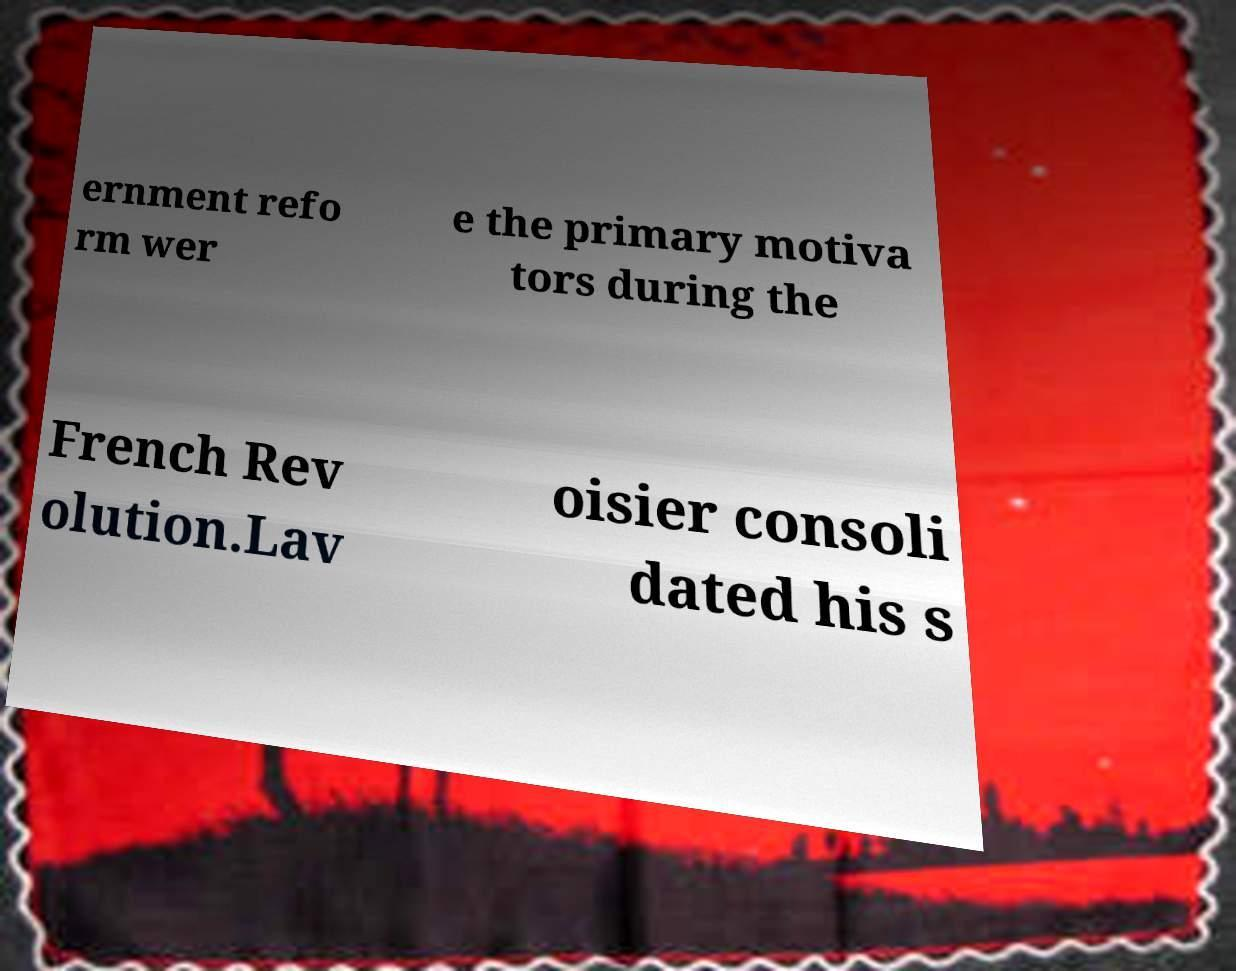Can you read and provide the text displayed in the image?This photo seems to have some interesting text. Can you extract and type it out for me? ernment refo rm wer e the primary motiva tors during the French Rev olution.Lav oisier consoli dated his s 